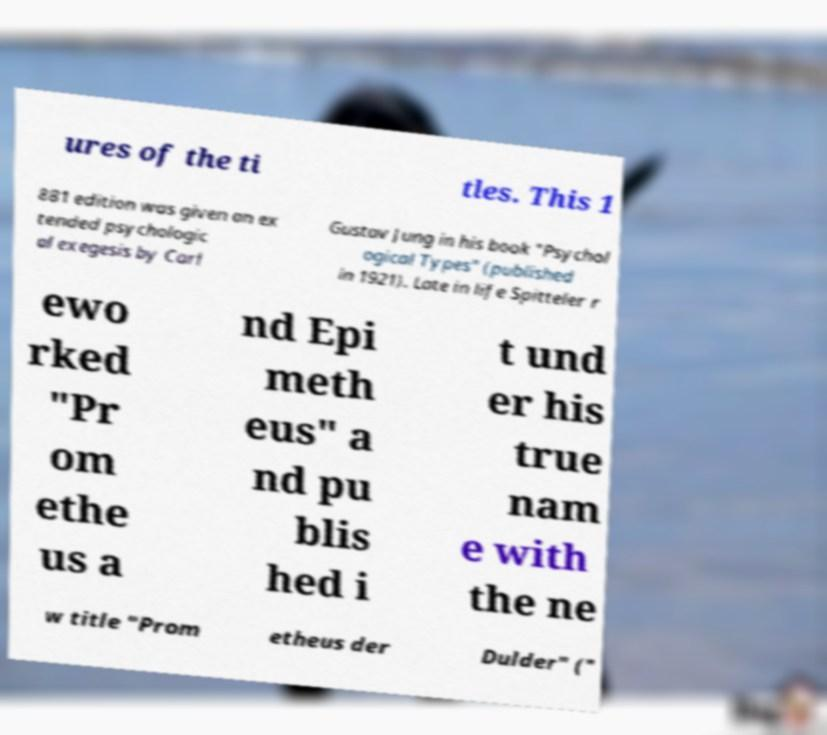I need the written content from this picture converted into text. Can you do that? ures of the ti tles. This 1 881 edition was given an ex tended psychologic al exegesis by Carl Gustav Jung in his book "Psychol ogical Types" (published in 1921). Late in life Spitteler r ewo rked "Pr om ethe us a nd Epi meth eus" a nd pu blis hed i t und er his true nam e with the ne w title "Prom etheus der Dulder" (" 